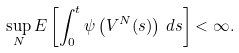<formula> <loc_0><loc_0><loc_500><loc_500>\sup _ { N } E \left [ \int _ { 0 } ^ { t } \psi \left ( V ^ { N } ( s ) \right ) \, d s \right ] < \infty .</formula> 